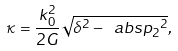Convert formula to latex. <formula><loc_0><loc_0><loc_500><loc_500>\kappa = \frac { k _ { 0 } ^ { 2 } } { 2 G } \sqrt { \delta ^ { 2 } - \ a b s { p _ { 2 } } ^ { 2 } } ,</formula> 